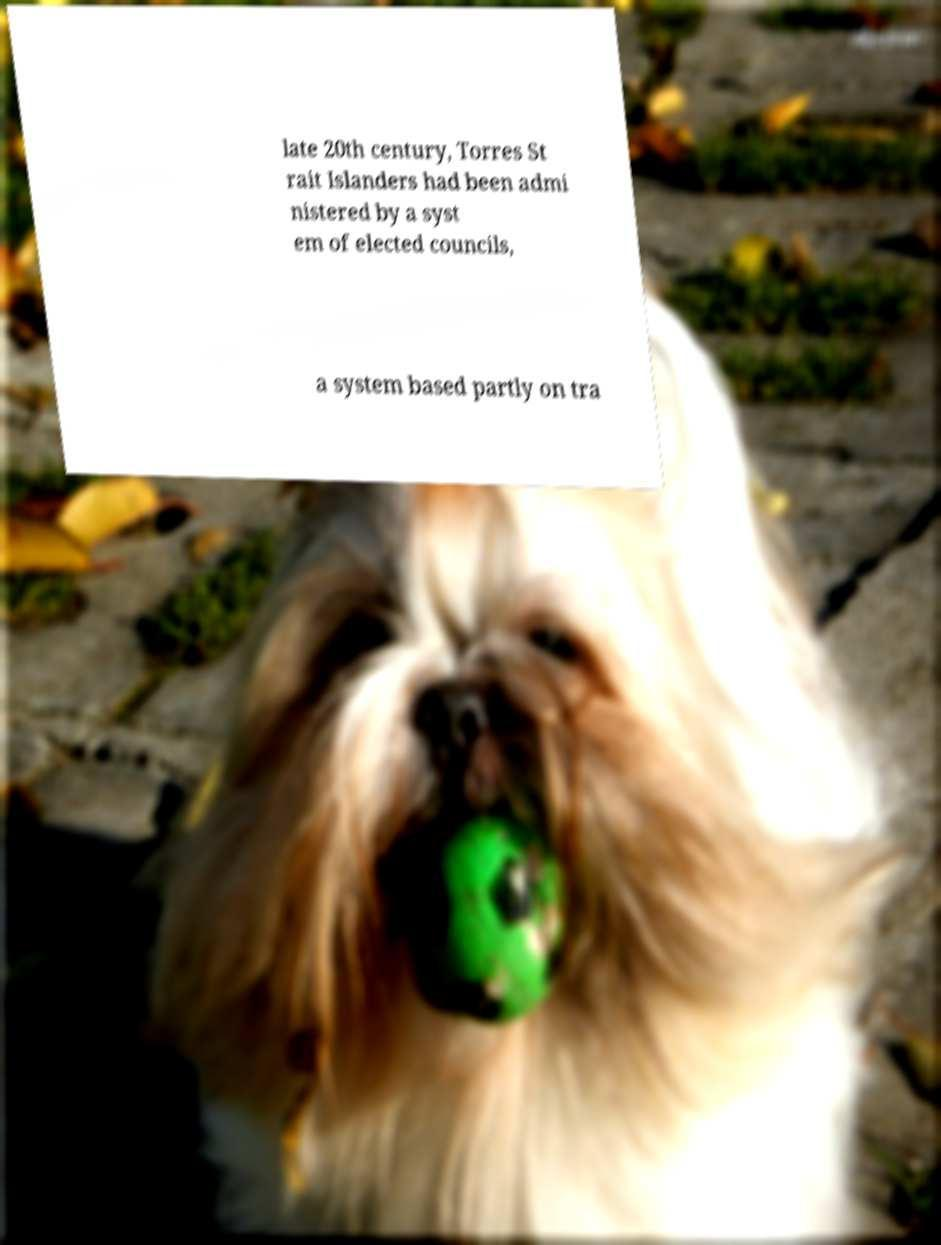Can you read and provide the text displayed in the image?This photo seems to have some interesting text. Can you extract and type it out for me? late 20th century, Torres St rait Islanders had been admi nistered by a syst em of elected councils, a system based partly on tra 